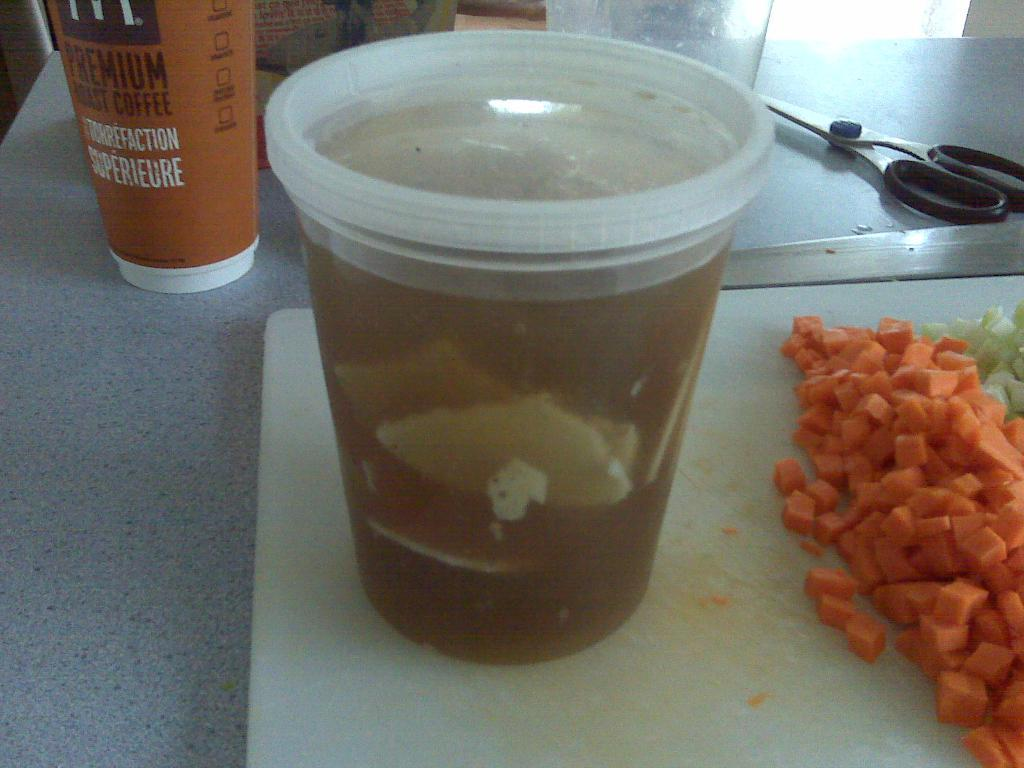What surface is visible in the image that is used for cutting or preparing food? There is a chopping board in the image. What tool is present in the image that is used for cutting? There are scissors in the image. What objects are present in the image that are typically used for drinking? There are glasses in the image. What type of food can be seen in the image that has been cut into pieces? There are carrot pieces in the image. Where are all of these objects placed in the image? All of these objects are placed on a table. What color ink is being used in the notebook in the image? There is no notebook or ink present in the image. Is the dog sitting on the table in the image? There is no dog present in the image. 